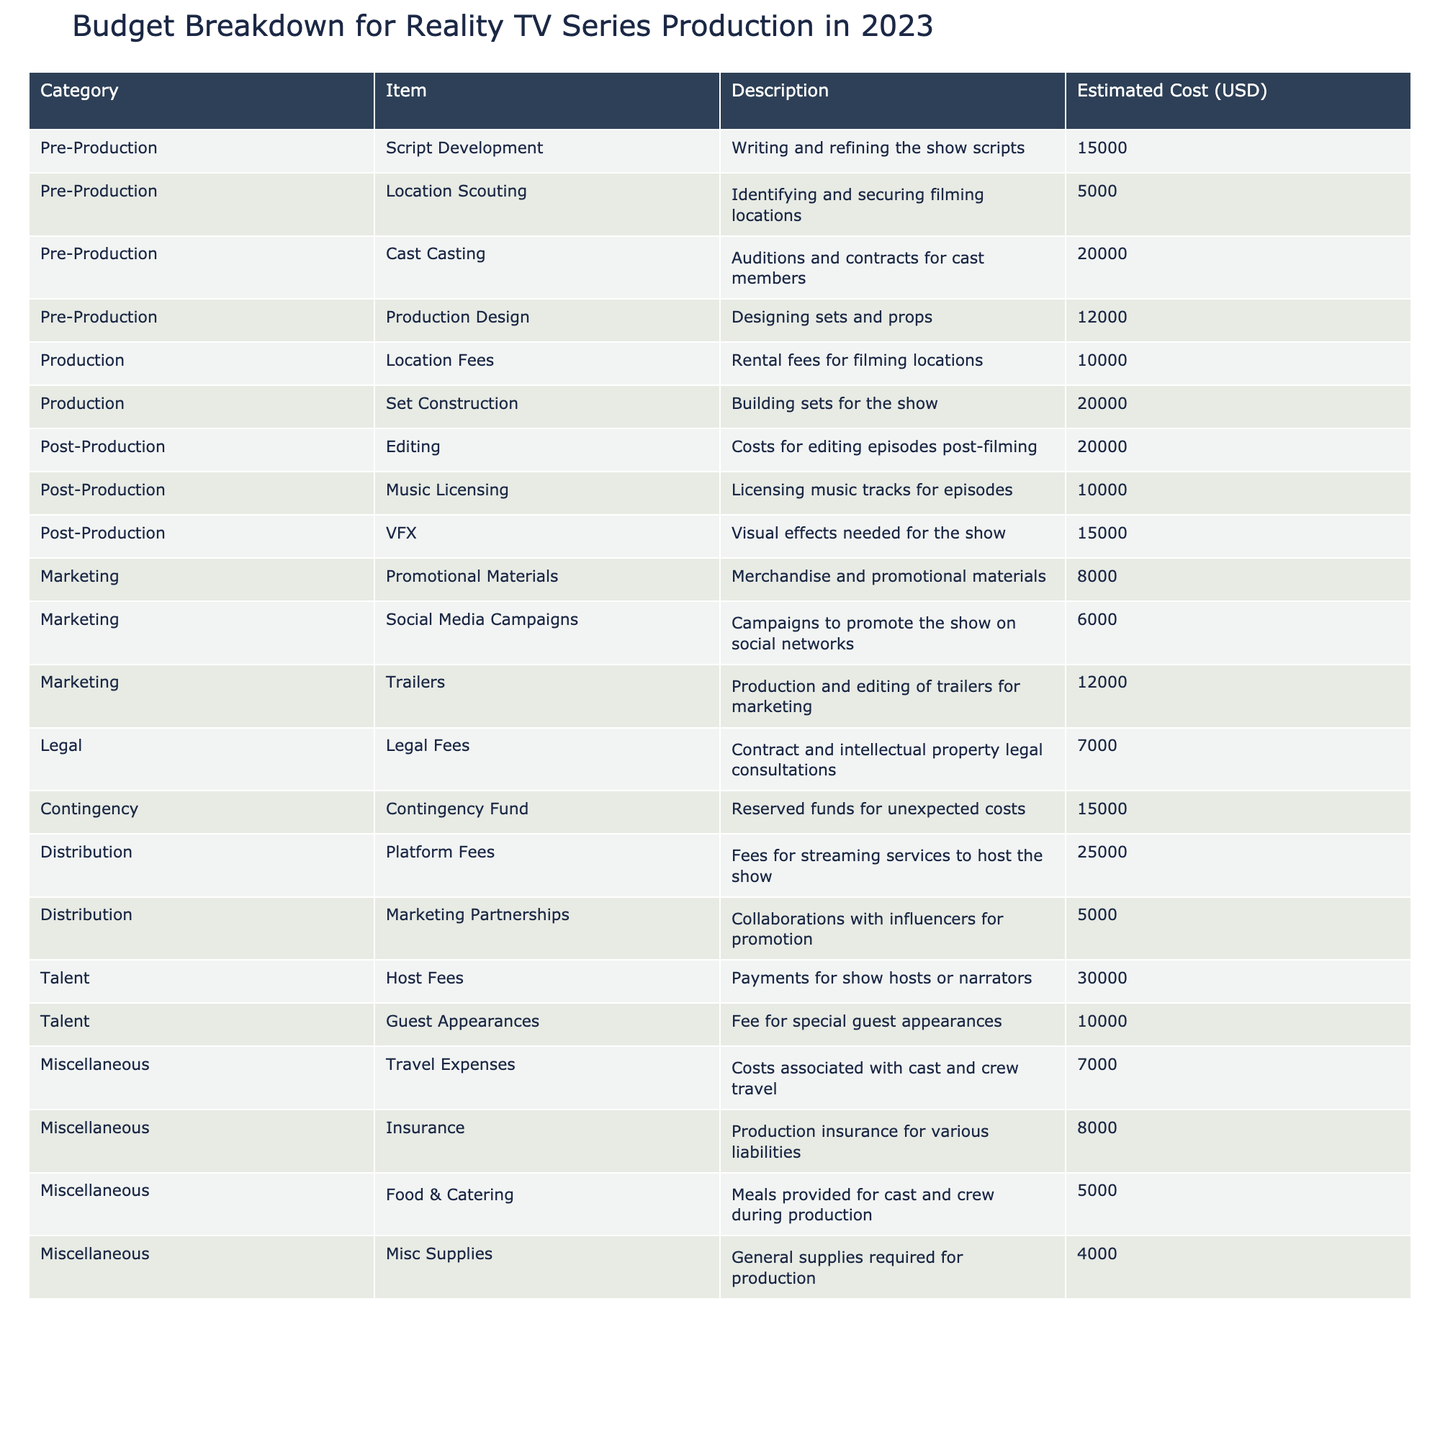What is the estimated cost for production design? The table lists "Production Design" under the "Pre-Production" category with an estimated cost of $12,000.
Answer: $12,000 How much is allocated for editing in post-production? The table specifies "Editing" in the "Post-Production" category with an estimated cost of $20,000.
Answer: $20,000 What is the total estimated cost for all marketing items? The marketing costs are $8,000 for promotional materials, $6,000 for social media campaigns, and $12,000 for trailers. Adding these together gives $8,000 + $6,000 + $12,000 = $26,000.
Answer: $26,000 Is the host fee higher than the sum of guest appearance fees and travel expenses? The host fee is $30,000, guest appearances are $10,000, and travel expenses are $7,000. The sum of guest appearances and travel expenses is $10,000 + $7,000 = $17,000, which is less than the host fee.
Answer: Yes What is the total estimated cost for production and post-production combined? In the Production category, the costs are $10,000 for location fees and $20,000 for set construction, totaling $30,000. In Post-Production, the costs are $20,000 for editing, $10,000 for music licensing, and $15,000 for VFX, totaling $45,000. Combining both gives $30,000 + $45,000 = $75,000.
Answer: $75,000 What percentage of the total budget is assigned to talent fees? The total estimated cost for talent fees (host fees and guest appearances) is $30,000 + $10,000 = $40,000. The overall budget is the sum of all items listed, which totals $266,000. Thus, the percentage is ($40,000 / $266,000) * 100 ≈ 15%.
Answer: 15% Which category has the highest estimated cost? By analyzing the table, the "Distribution" category has the largest item, with "Platform Fees" costing $25,000, while no other category has a cost exceeding this amount.
Answer: Distribution How much did we allocate for contingency funds versus legal fees? The contingency fund is $15,000 and legal fees are $7,000. Since $15,000 is greater than $7,000, we allocated more for contingency funds.
Answer: Contingency funds are higher What is the total cost of all items categorized as miscellaneous? The miscellaneous items are $7,000 for travel expenses, $8,000 for insurance, $5,000 for food & catering, and $4,000 for miscellaneous supplies. Adding these gives $7,000 + $8,000 + $5,000 + $4,000 = $24,000.
Answer: $24,000 If we sum all costs of pre-production, will it exceed the total of post-production costs? For pre-production, costs total $15,000 + $5,000 + $20,000 + $12,000 = $52,000. For post-production, the total is $20,000 + $10,000 + $15,000 = $45,000. Since $52,000 > $45,000, pre-production exceeds post-production.
Answer: Yes 